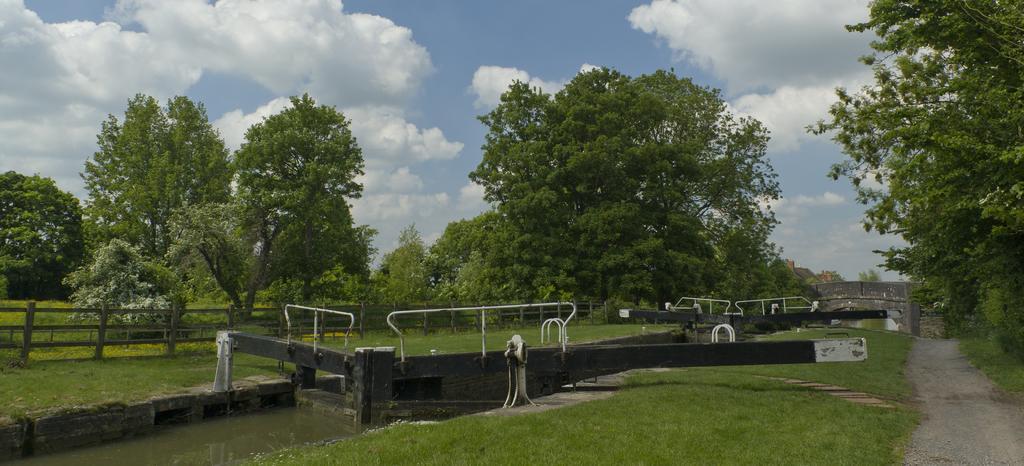In one or two sentences, can you explain what this image depicts? This picture shows few trees and we see a canal and a bridge and we see a wooden fence and grass on the ground and a blue cloudy sky. 